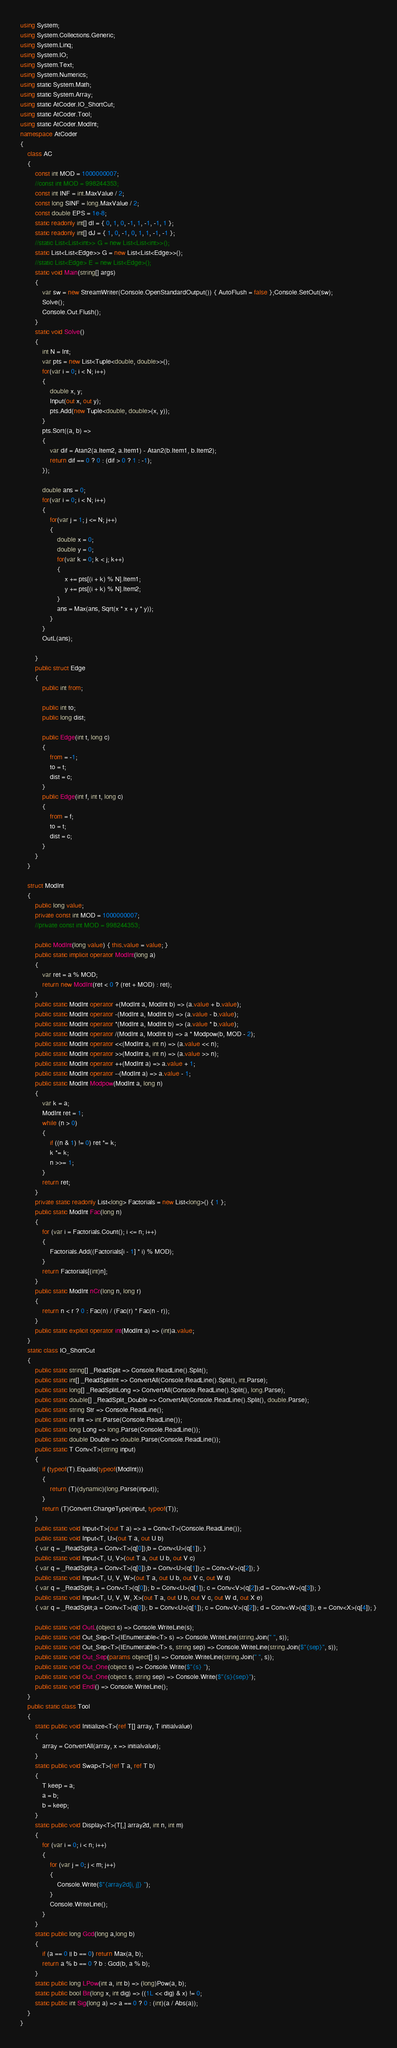Convert code to text. <code><loc_0><loc_0><loc_500><loc_500><_C#_>using System;
using System.Collections.Generic;
using System.Linq;
using System.IO;
using System.Text;
using System.Numerics;
using static System.Math;
using static System.Array;
using static AtCoder.IO_ShortCut;
using static AtCoder.Tool;
using static AtCoder.ModInt;
namespace AtCoder
{
    class AC
    {
        const int MOD = 1000000007;
        //const int MOD = 998244353;
        const int INF = int.MaxValue / 2;
        const long SINF = long.MaxValue / 2;
        const double EPS = 1e-8;
        static readonly int[] dI = { 0, 1, 0, -1, 1, -1, -1, 1 };
        static readonly int[] dJ = { 1, 0, -1, 0, 1, 1, -1, -1 };
        //static List<List<int>> G = new List<List<int>>();
        static List<List<Edge>> G = new List<List<Edge>>();
        //static List<Edge> E = new List<Edge>();
        static void Main(string[] args)
        {
            var sw = new StreamWriter(Console.OpenStandardOutput()) { AutoFlush = false };Console.SetOut(sw);
            Solve();
            Console.Out.Flush();
        }
        static void Solve()
        {
            int N = Int;
            var pts = new List<Tuple<double, double>>();
            for(var i = 0; i < N; i++)
            {
                double x, y;
                Input(out x, out y);
                pts.Add(new Tuple<double, double>(x, y));
            }
            pts.Sort((a, b) =>
            {
                var dif = Atan2(a.Item2, a.Item1) - Atan2(b.Item1, b.Item2);
                return dif == 0 ? 0 : (dif > 0 ? 1 : -1);
            });

            double ans = 0;
            for(var i = 0; i < N; i++)
            {
                for(var j = 1; j <= N; j++)
                {
                    double x = 0;
                    double y = 0;
                    for(var k = 0; k < j; k++)
                    {
                        x += pts[(i + k) % N].Item1;
                        y += pts[(i + k) % N].Item2;
                    }
                    ans = Max(ans, Sqrt(x * x + y * y));
                }
            }
            OutL(ans);

        }
        public struct Edge
        {
            public int from;

            public int to;
            public long dist;
            
            public Edge(int t, long c)
            {
                from = -1;
                to = t;
                dist = c;
            }
            public Edge(int f, int t, long c)
            {
                from = f;
                to = t;
                dist = c;
            }
        }
    }
    
    struct ModInt
    {
        public long value;
        private const int MOD = 1000000007;
        //private const int MOD = 998244353;

        public ModInt(long value) { this.value = value; }
        public static implicit operator ModInt(long a)
        {
            var ret = a % MOD;
            return new ModInt(ret < 0 ? (ret + MOD) : ret);
        }
        public static ModInt operator +(ModInt a, ModInt b) => (a.value + b.value);
        public static ModInt operator -(ModInt a, ModInt b) => (a.value - b.value);
        public static ModInt operator *(ModInt a, ModInt b) => (a.value * b.value);
        public static ModInt operator /(ModInt a, ModInt b) => a * Modpow(b, MOD - 2);
        public static ModInt operator <<(ModInt a, int n) => (a.value << n);
        public static ModInt operator >>(ModInt a, int n) => (a.value >> n);
        public static ModInt operator ++(ModInt a) => a.value + 1;
        public static ModInt operator --(ModInt a) => a.value - 1;
        public static ModInt Modpow(ModInt a, long n)
        {
            var k = a;
            ModInt ret = 1;
            while (n > 0)
            {
                if ((n & 1) != 0) ret *= k;
                k *= k;
                n >>= 1;
            }
            return ret;
        }
        private static readonly List<long> Factorials = new List<long>() { 1 };
        public static ModInt Fac(long n)
        {
            for (var i = Factorials.Count(); i <= n; i++)
            {
                Factorials.Add((Factorials[i - 1] * i) % MOD);
            }
            return Factorials[(int)n];
        }
        public static ModInt nCr(long n, long r)
        {
            return n < r ? 0 : Fac(n) / (Fac(r) * Fac(n - r));
        }
        public static explicit operator int(ModInt a) => (int)a.value;
    }
    static class IO_ShortCut
    {
        public static string[] _ReadSplit => Console.ReadLine().Split();
        public static int[] _ReadSplitInt => ConvertAll(Console.ReadLine().Split(), int.Parse);
        public static long[] _ReadSplitLong => ConvertAll(Console.ReadLine().Split(), long.Parse);
        public static double[] _ReadSplit_Double => ConvertAll(Console.ReadLine().Split(), double.Parse);
        public static string Str => Console.ReadLine();
        public static int Int => int.Parse(Console.ReadLine());
        public static long Long => long.Parse(Console.ReadLine());
        public static double Double => double.Parse(Console.ReadLine());
        public static T Conv<T>(string input)
        {
            if (typeof(T).Equals(typeof(ModInt)))
            {
                return (T)(dynamic)(long.Parse(input));
            }
            return (T)Convert.ChangeType(input, typeof(T));
        }
        public static void Input<T>(out T a) => a = Conv<T>(Console.ReadLine());
        public static void Input<T, U>(out T a, out U b)
        { var q = _ReadSplit;a = Conv<T>(q[0]);b = Conv<U>(q[1]); }
        public static void Input<T, U, V>(out T a, out U b, out V c)
        { var q = _ReadSplit;a = Conv<T>(q[0]);b = Conv<U>(q[1]);c = Conv<V>(q[2]); }
        public static void Input<T, U, V, W>(out T a, out U b, out V c, out W d)
        { var q = _ReadSplit; a = Conv<T>(q[0]); b = Conv<U>(q[1]); c = Conv<V>(q[2]);d = Conv<W>(q[3]); }
        public static void Input<T, U, V, W, X>(out T a, out U b, out V c, out W d, out X e)
        { var q = _ReadSplit;a = Conv<T>(q[0]); b = Conv<U>(q[1]); c = Conv<V>(q[2]); d = Conv<W>(q[3]); e = Conv<X>(q[4]); }

        public static void OutL(object s) => Console.WriteLine(s);
        public static void Out_Sep<T>(IEnumerable<T> s) => Console.WriteLine(string.Join(" ", s));
        public static void Out_Sep<T>(IEnumerable<T> s, string sep) => Console.WriteLine(string.Join($"{sep}", s));
        public static void Out_Sep(params object[] s) => Console.WriteLine(string.Join(" ", s));
        public static void Out_One(object s) => Console.Write($"{s} ");
        public static void Out_One(object s, string sep) => Console.Write($"{s}{sep}");
        public static void Endl() => Console.WriteLine();
    }
    public static class Tool
    {
        static public void Initialize<T>(ref T[] array, T initialvalue)
        {
            array = ConvertAll(array, x => initialvalue);
        }
        static public void Swap<T>(ref T a, ref T b)
        {
            T keep = a;
            a = b;
            b = keep;
        }
        static public void Display<T>(T[,] array2d, int n, int m)
        {
            for (var i = 0; i < n; i++)
            {
                for (var j = 0; j < m; j++)
                {
                    Console.Write($"{array2d[i, j]} ");
                }
                Console.WriteLine();
            }
        }
        static public long Gcd(long a,long b)
        {
            if (a == 0 || b == 0) return Max(a, b);
            return a % b == 0 ? b : Gcd(b, a % b);
        }
        static public long LPow(int a, int b) => (long)Pow(a, b);
        static public bool Bit(long x, int dig) => ((1L << dig) & x) != 0;
        static public int Sig(long a) => a == 0 ? 0 : (int)(a / Abs(a));
    }
}</code> 